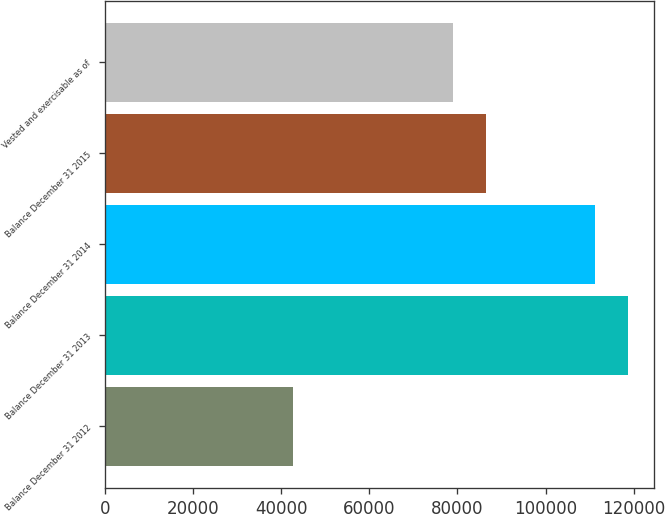Convert chart. <chart><loc_0><loc_0><loc_500><loc_500><bar_chart><fcel>Balance December 31 2012<fcel>Balance December 31 2013<fcel>Balance December 31 2014<fcel>Balance December 31 2015<fcel>Vested and exercisable as of<nl><fcel>42647<fcel>118681<fcel>111277<fcel>86502.9<fcel>79099<nl></chart> 